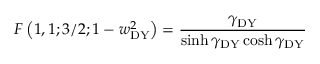Convert formula to latex. <formula><loc_0><loc_0><loc_500><loc_500>F \left ( 1 , 1 ; 3 / 2 ; 1 - w _ { D Y } ^ { 2 } \right ) = \frac { \gamma _ { D Y } } { \sinh \gamma _ { D Y } \cosh \gamma _ { D Y } }</formula> 